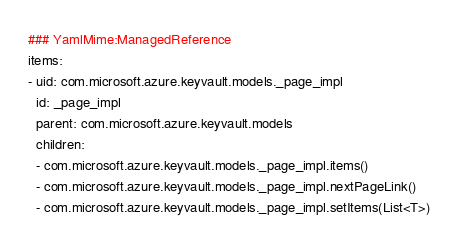Convert code to text. <code><loc_0><loc_0><loc_500><loc_500><_YAML_>### YamlMime:ManagedReference
items:
- uid: com.microsoft.azure.keyvault.models._page_impl
  id: _page_impl
  parent: com.microsoft.azure.keyvault.models
  children:
  - com.microsoft.azure.keyvault.models._page_impl.items()
  - com.microsoft.azure.keyvault.models._page_impl.nextPageLink()
  - com.microsoft.azure.keyvault.models._page_impl.setItems(List<T>)</code> 